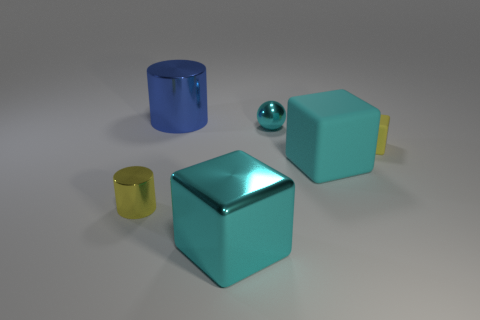Add 2 tiny metal balls. How many objects exist? 8 Subtract all cylinders. How many objects are left? 4 Subtract all small objects. Subtract all cyan matte things. How many objects are left? 2 Add 4 yellow cubes. How many yellow cubes are left? 5 Add 1 tiny gray spheres. How many tiny gray spheres exist? 1 Subtract 0 green spheres. How many objects are left? 6 